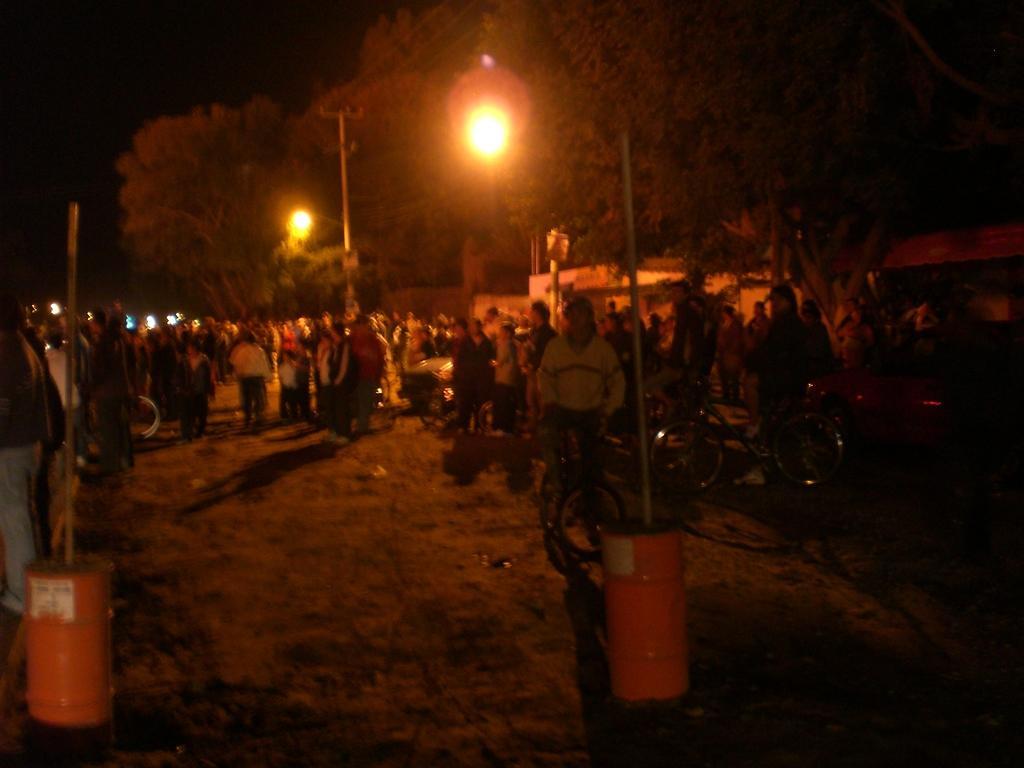How would you summarize this image in a sentence or two? In this picture we can see a group of people on the ground, here we can see bicycles, electric pole, drums with poles, trees, lights, houses and some objects and in the background we can see it is dark. 